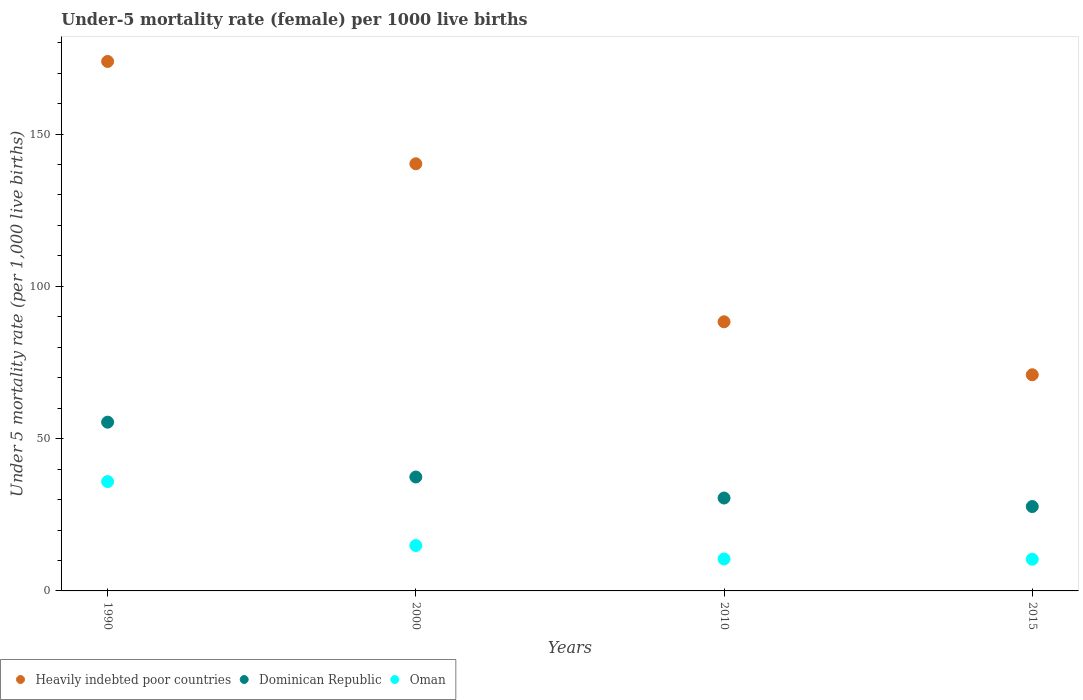Is the number of dotlines equal to the number of legend labels?
Make the answer very short. Yes. What is the under-five mortality rate in Dominican Republic in 1990?
Keep it short and to the point. 55.4. Across all years, what is the maximum under-five mortality rate in Heavily indebted poor countries?
Keep it short and to the point. 173.83. Across all years, what is the minimum under-five mortality rate in Heavily indebted poor countries?
Keep it short and to the point. 70.97. In which year was the under-five mortality rate in Heavily indebted poor countries minimum?
Your answer should be compact. 2015. What is the total under-five mortality rate in Oman in the graph?
Provide a short and direct response. 71.7. What is the difference between the under-five mortality rate in Heavily indebted poor countries in 2010 and that in 2015?
Your answer should be very brief. 17.39. What is the difference between the under-five mortality rate in Oman in 1990 and the under-five mortality rate in Dominican Republic in 2010?
Ensure brevity in your answer.  5.4. What is the average under-five mortality rate in Dominican Republic per year?
Provide a succinct answer. 37.75. In the year 1990, what is the difference between the under-five mortality rate in Dominican Republic and under-five mortality rate in Heavily indebted poor countries?
Your answer should be compact. -118.43. In how many years, is the under-five mortality rate in Heavily indebted poor countries greater than 20?
Your answer should be compact. 4. What is the ratio of the under-five mortality rate in Heavily indebted poor countries in 1990 to that in 2010?
Provide a short and direct response. 1.97. What is the difference between the highest and the lowest under-five mortality rate in Heavily indebted poor countries?
Make the answer very short. 102.86. Is the sum of the under-five mortality rate in Oman in 2000 and 2015 greater than the maximum under-five mortality rate in Heavily indebted poor countries across all years?
Your answer should be compact. No. Is it the case that in every year, the sum of the under-five mortality rate in Heavily indebted poor countries and under-five mortality rate in Oman  is greater than the under-five mortality rate in Dominican Republic?
Your answer should be very brief. Yes. Does the under-five mortality rate in Oman monotonically increase over the years?
Offer a very short reply. No. Is the under-five mortality rate in Dominican Republic strictly greater than the under-five mortality rate in Heavily indebted poor countries over the years?
Offer a very short reply. No. How many years are there in the graph?
Ensure brevity in your answer.  4. Does the graph contain any zero values?
Offer a terse response. No. Where does the legend appear in the graph?
Make the answer very short. Bottom left. What is the title of the graph?
Provide a succinct answer. Under-5 mortality rate (female) per 1000 live births. Does "South Sudan" appear as one of the legend labels in the graph?
Keep it short and to the point. No. What is the label or title of the Y-axis?
Offer a terse response. Under 5 mortality rate (per 1,0 live births). What is the Under 5 mortality rate (per 1,000 live births) in Heavily indebted poor countries in 1990?
Provide a short and direct response. 173.83. What is the Under 5 mortality rate (per 1,000 live births) of Dominican Republic in 1990?
Keep it short and to the point. 55.4. What is the Under 5 mortality rate (per 1,000 live births) in Oman in 1990?
Make the answer very short. 35.9. What is the Under 5 mortality rate (per 1,000 live births) of Heavily indebted poor countries in 2000?
Make the answer very short. 140.23. What is the Under 5 mortality rate (per 1,000 live births) of Dominican Republic in 2000?
Offer a very short reply. 37.4. What is the Under 5 mortality rate (per 1,000 live births) in Heavily indebted poor countries in 2010?
Your answer should be compact. 88.36. What is the Under 5 mortality rate (per 1,000 live births) in Dominican Republic in 2010?
Ensure brevity in your answer.  30.5. What is the Under 5 mortality rate (per 1,000 live births) of Heavily indebted poor countries in 2015?
Offer a very short reply. 70.97. What is the Under 5 mortality rate (per 1,000 live births) of Dominican Republic in 2015?
Give a very brief answer. 27.7. Across all years, what is the maximum Under 5 mortality rate (per 1,000 live births) of Heavily indebted poor countries?
Your answer should be very brief. 173.83. Across all years, what is the maximum Under 5 mortality rate (per 1,000 live births) in Dominican Republic?
Your answer should be very brief. 55.4. Across all years, what is the maximum Under 5 mortality rate (per 1,000 live births) in Oman?
Provide a short and direct response. 35.9. Across all years, what is the minimum Under 5 mortality rate (per 1,000 live births) in Heavily indebted poor countries?
Ensure brevity in your answer.  70.97. Across all years, what is the minimum Under 5 mortality rate (per 1,000 live births) of Dominican Republic?
Your answer should be compact. 27.7. Across all years, what is the minimum Under 5 mortality rate (per 1,000 live births) of Oman?
Keep it short and to the point. 10.4. What is the total Under 5 mortality rate (per 1,000 live births) in Heavily indebted poor countries in the graph?
Ensure brevity in your answer.  473.39. What is the total Under 5 mortality rate (per 1,000 live births) of Dominican Republic in the graph?
Give a very brief answer. 151. What is the total Under 5 mortality rate (per 1,000 live births) in Oman in the graph?
Offer a very short reply. 71.7. What is the difference between the Under 5 mortality rate (per 1,000 live births) of Heavily indebted poor countries in 1990 and that in 2000?
Your answer should be very brief. 33.59. What is the difference between the Under 5 mortality rate (per 1,000 live births) of Dominican Republic in 1990 and that in 2000?
Provide a short and direct response. 18. What is the difference between the Under 5 mortality rate (per 1,000 live births) of Heavily indebted poor countries in 1990 and that in 2010?
Your answer should be compact. 85.47. What is the difference between the Under 5 mortality rate (per 1,000 live births) of Dominican Republic in 1990 and that in 2010?
Your answer should be very brief. 24.9. What is the difference between the Under 5 mortality rate (per 1,000 live births) of Oman in 1990 and that in 2010?
Give a very brief answer. 25.4. What is the difference between the Under 5 mortality rate (per 1,000 live births) of Heavily indebted poor countries in 1990 and that in 2015?
Offer a very short reply. 102.86. What is the difference between the Under 5 mortality rate (per 1,000 live births) in Dominican Republic in 1990 and that in 2015?
Keep it short and to the point. 27.7. What is the difference between the Under 5 mortality rate (per 1,000 live births) of Heavily indebted poor countries in 2000 and that in 2010?
Your answer should be compact. 51.87. What is the difference between the Under 5 mortality rate (per 1,000 live births) in Oman in 2000 and that in 2010?
Keep it short and to the point. 4.4. What is the difference between the Under 5 mortality rate (per 1,000 live births) in Heavily indebted poor countries in 2000 and that in 2015?
Provide a succinct answer. 69.27. What is the difference between the Under 5 mortality rate (per 1,000 live births) in Dominican Republic in 2000 and that in 2015?
Your answer should be compact. 9.7. What is the difference between the Under 5 mortality rate (per 1,000 live births) in Heavily indebted poor countries in 2010 and that in 2015?
Offer a very short reply. 17.39. What is the difference between the Under 5 mortality rate (per 1,000 live births) in Dominican Republic in 2010 and that in 2015?
Give a very brief answer. 2.8. What is the difference between the Under 5 mortality rate (per 1,000 live births) of Oman in 2010 and that in 2015?
Offer a terse response. 0.1. What is the difference between the Under 5 mortality rate (per 1,000 live births) of Heavily indebted poor countries in 1990 and the Under 5 mortality rate (per 1,000 live births) of Dominican Republic in 2000?
Offer a very short reply. 136.43. What is the difference between the Under 5 mortality rate (per 1,000 live births) of Heavily indebted poor countries in 1990 and the Under 5 mortality rate (per 1,000 live births) of Oman in 2000?
Provide a short and direct response. 158.93. What is the difference between the Under 5 mortality rate (per 1,000 live births) of Dominican Republic in 1990 and the Under 5 mortality rate (per 1,000 live births) of Oman in 2000?
Ensure brevity in your answer.  40.5. What is the difference between the Under 5 mortality rate (per 1,000 live births) of Heavily indebted poor countries in 1990 and the Under 5 mortality rate (per 1,000 live births) of Dominican Republic in 2010?
Ensure brevity in your answer.  143.33. What is the difference between the Under 5 mortality rate (per 1,000 live births) of Heavily indebted poor countries in 1990 and the Under 5 mortality rate (per 1,000 live births) of Oman in 2010?
Ensure brevity in your answer.  163.33. What is the difference between the Under 5 mortality rate (per 1,000 live births) in Dominican Republic in 1990 and the Under 5 mortality rate (per 1,000 live births) in Oman in 2010?
Provide a short and direct response. 44.9. What is the difference between the Under 5 mortality rate (per 1,000 live births) of Heavily indebted poor countries in 1990 and the Under 5 mortality rate (per 1,000 live births) of Dominican Republic in 2015?
Ensure brevity in your answer.  146.13. What is the difference between the Under 5 mortality rate (per 1,000 live births) of Heavily indebted poor countries in 1990 and the Under 5 mortality rate (per 1,000 live births) of Oman in 2015?
Keep it short and to the point. 163.43. What is the difference between the Under 5 mortality rate (per 1,000 live births) of Dominican Republic in 1990 and the Under 5 mortality rate (per 1,000 live births) of Oman in 2015?
Offer a terse response. 45. What is the difference between the Under 5 mortality rate (per 1,000 live births) in Heavily indebted poor countries in 2000 and the Under 5 mortality rate (per 1,000 live births) in Dominican Republic in 2010?
Offer a terse response. 109.73. What is the difference between the Under 5 mortality rate (per 1,000 live births) of Heavily indebted poor countries in 2000 and the Under 5 mortality rate (per 1,000 live births) of Oman in 2010?
Offer a terse response. 129.73. What is the difference between the Under 5 mortality rate (per 1,000 live births) in Dominican Republic in 2000 and the Under 5 mortality rate (per 1,000 live births) in Oman in 2010?
Provide a succinct answer. 26.9. What is the difference between the Under 5 mortality rate (per 1,000 live births) of Heavily indebted poor countries in 2000 and the Under 5 mortality rate (per 1,000 live births) of Dominican Republic in 2015?
Make the answer very short. 112.53. What is the difference between the Under 5 mortality rate (per 1,000 live births) in Heavily indebted poor countries in 2000 and the Under 5 mortality rate (per 1,000 live births) in Oman in 2015?
Offer a very short reply. 129.83. What is the difference between the Under 5 mortality rate (per 1,000 live births) of Dominican Republic in 2000 and the Under 5 mortality rate (per 1,000 live births) of Oman in 2015?
Offer a very short reply. 27. What is the difference between the Under 5 mortality rate (per 1,000 live births) in Heavily indebted poor countries in 2010 and the Under 5 mortality rate (per 1,000 live births) in Dominican Republic in 2015?
Make the answer very short. 60.66. What is the difference between the Under 5 mortality rate (per 1,000 live births) in Heavily indebted poor countries in 2010 and the Under 5 mortality rate (per 1,000 live births) in Oman in 2015?
Keep it short and to the point. 77.96. What is the difference between the Under 5 mortality rate (per 1,000 live births) in Dominican Republic in 2010 and the Under 5 mortality rate (per 1,000 live births) in Oman in 2015?
Your answer should be very brief. 20.1. What is the average Under 5 mortality rate (per 1,000 live births) of Heavily indebted poor countries per year?
Keep it short and to the point. 118.35. What is the average Under 5 mortality rate (per 1,000 live births) of Dominican Republic per year?
Make the answer very short. 37.75. What is the average Under 5 mortality rate (per 1,000 live births) in Oman per year?
Keep it short and to the point. 17.93. In the year 1990, what is the difference between the Under 5 mortality rate (per 1,000 live births) of Heavily indebted poor countries and Under 5 mortality rate (per 1,000 live births) of Dominican Republic?
Provide a short and direct response. 118.43. In the year 1990, what is the difference between the Under 5 mortality rate (per 1,000 live births) in Heavily indebted poor countries and Under 5 mortality rate (per 1,000 live births) in Oman?
Offer a very short reply. 137.93. In the year 2000, what is the difference between the Under 5 mortality rate (per 1,000 live births) in Heavily indebted poor countries and Under 5 mortality rate (per 1,000 live births) in Dominican Republic?
Your response must be concise. 102.83. In the year 2000, what is the difference between the Under 5 mortality rate (per 1,000 live births) in Heavily indebted poor countries and Under 5 mortality rate (per 1,000 live births) in Oman?
Offer a terse response. 125.33. In the year 2010, what is the difference between the Under 5 mortality rate (per 1,000 live births) of Heavily indebted poor countries and Under 5 mortality rate (per 1,000 live births) of Dominican Republic?
Your response must be concise. 57.86. In the year 2010, what is the difference between the Under 5 mortality rate (per 1,000 live births) in Heavily indebted poor countries and Under 5 mortality rate (per 1,000 live births) in Oman?
Provide a short and direct response. 77.86. In the year 2015, what is the difference between the Under 5 mortality rate (per 1,000 live births) of Heavily indebted poor countries and Under 5 mortality rate (per 1,000 live births) of Dominican Republic?
Your response must be concise. 43.27. In the year 2015, what is the difference between the Under 5 mortality rate (per 1,000 live births) in Heavily indebted poor countries and Under 5 mortality rate (per 1,000 live births) in Oman?
Offer a terse response. 60.57. In the year 2015, what is the difference between the Under 5 mortality rate (per 1,000 live births) in Dominican Republic and Under 5 mortality rate (per 1,000 live births) in Oman?
Provide a short and direct response. 17.3. What is the ratio of the Under 5 mortality rate (per 1,000 live births) of Heavily indebted poor countries in 1990 to that in 2000?
Ensure brevity in your answer.  1.24. What is the ratio of the Under 5 mortality rate (per 1,000 live births) of Dominican Republic in 1990 to that in 2000?
Your answer should be very brief. 1.48. What is the ratio of the Under 5 mortality rate (per 1,000 live births) in Oman in 1990 to that in 2000?
Make the answer very short. 2.41. What is the ratio of the Under 5 mortality rate (per 1,000 live births) in Heavily indebted poor countries in 1990 to that in 2010?
Your answer should be very brief. 1.97. What is the ratio of the Under 5 mortality rate (per 1,000 live births) in Dominican Republic in 1990 to that in 2010?
Provide a short and direct response. 1.82. What is the ratio of the Under 5 mortality rate (per 1,000 live births) in Oman in 1990 to that in 2010?
Your response must be concise. 3.42. What is the ratio of the Under 5 mortality rate (per 1,000 live births) of Heavily indebted poor countries in 1990 to that in 2015?
Offer a very short reply. 2.45. What is the ratio of the Under 5 mortality rate (per 1,000 live births) in Dominican Republic in 1990 to that in 2015?
Your response must be concise. 2. What is the ratio of the Under 5 mortality rate (per 1,000 live births) of Oman in 1990 to that in 2015?
Provide a short and direct response. 3.45. What is the ratio of the Under 5 mortality rate (per 1,000 live births) in Heavily indebted poor countries in 2000 to that in 2010?
Give a very brief answer. 1.59. What is the ratio of the Under 5 mortality rate (per 1,000 live births) in Dominican Republic in 2000 to that in 2010?
Offer a terse response. 1.23. What is the ratio of the Under 5 mortality rate (per 1,000 live births) in Oman in 2000 to that in 2010?
Provide a succinct answer. 1.42. What is the ratio of the Under 5 mortality rate (per 1,000 live births) in Heavily indebted poor countries in 2000 to that in 2015?
Provide a short and direct response. 1.98. What is the ratio of the Under 5 mortality rate (per 1,000 live births) of Dominican Republic in 2000 to that in 2015?
Keep it short and to the point. 1.35. What is the ratio of the Under 5 mortality rate (per 1,000 live births) in Oman in 2000 to that in 2015?
Keep it short and to the point. 1.43. What is the ratio of the Under 5 mortality rate (per 1,000 live births) in Heavily indebted poor countries in 2010 to that in 2015?
Your answer should be compact. 1.25. What is the ratio of the Under 5 mortality rate (per 1,000 live births) of Dominican Republic in 2010 to that in 2015?
Offer a terse response. 1.1. What is the ratio of the Under 5 mortality rate (per 1,000 live births) of Oman in 2010 to that in 2015?
Your response must be concise. 1.01. What is the difference between the highest and the second highest Under 5 mortality rate (per 1,000 live births) of Heavily indebted poor countries?
Offer a very short reply. 33.59. What is the difference between the highest and the lowest Under 5 mortality rate (per 1,000 live births) in Heavily indebted poor countries?
Offer a terse response. 102.86. What is the difference between the highest and the lowest Under 5 mortality rate (per 1,000 live births) of Dominican Republic?
Offer a terse response. 27.7. What is the difference between the highest and the lowest Under 5 mortality rate (per 1,000 live births) in Oman?
Offer a terse response. 25.5. 